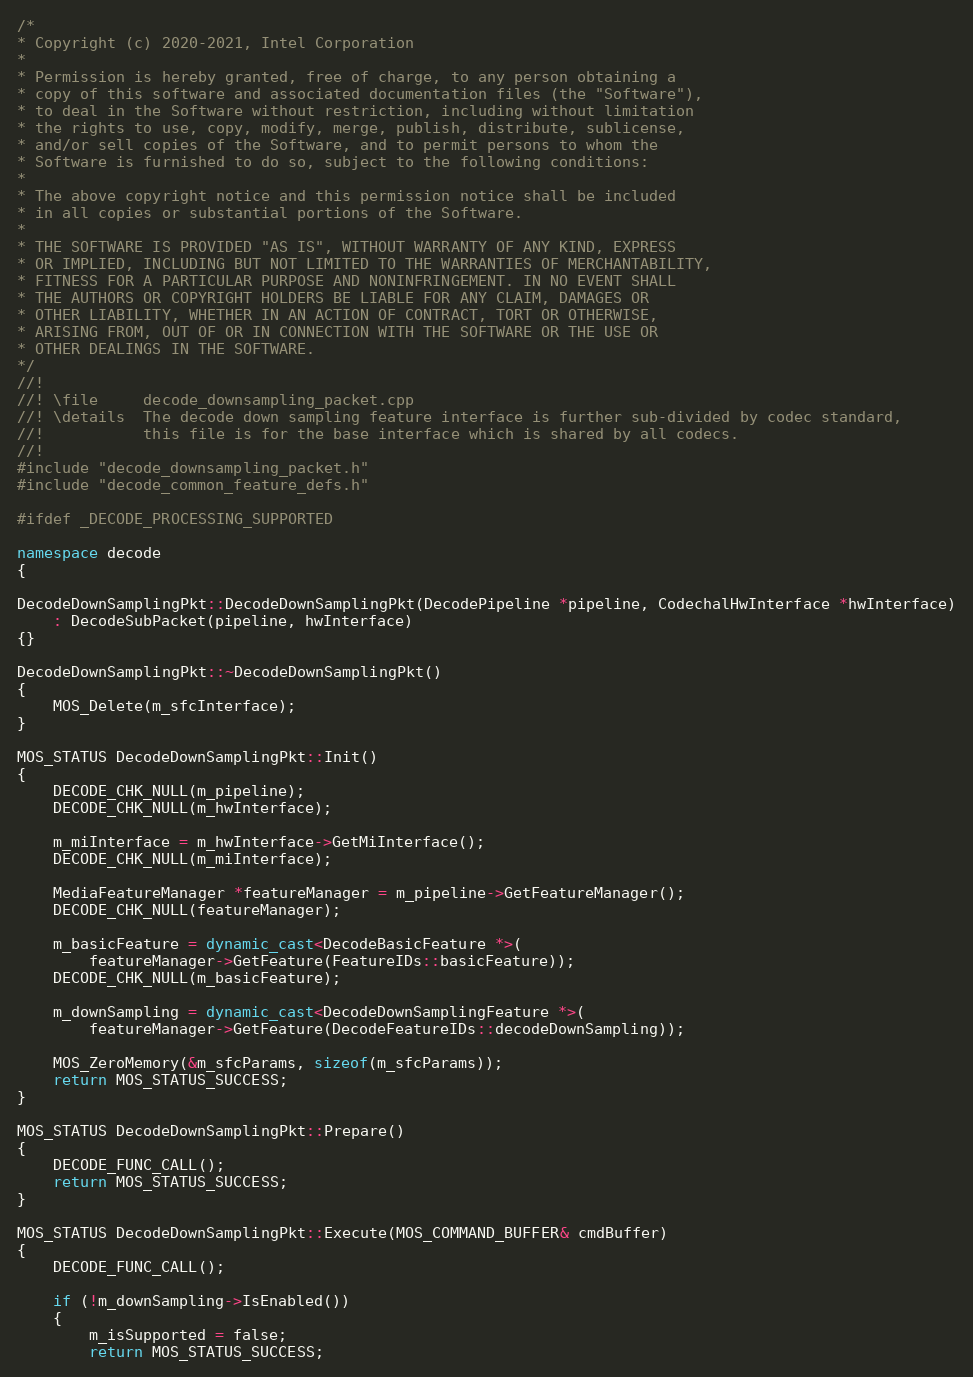<code> <loc_0><loc_0><loc_500><loc_500><_C++_>/*
* Copyright (c) 2020-2021, Intel Corporation
*
* Permission is hereby granted, free of charge, to any person obtaining a
* copy of this software and associated documentation files (the "Software"),
* to deal in the Software without restriction, including without limitation
* the rights to use, copy, modify, merge, publish, distribute, sublicense,
* and/or sell copies of the Software, and to permit persons to whom the
* Software is furnished to do so, subject to the following conditions:
*
* The above copyright notice and this permission notice shall be included
* in all copies or substantial portions of the Software.
*
* THE SOFTWARE IS PROVIDED "AS IS", WITHOUT WARRANTY OF ANY KIND, EXPRESS
* OR IMPLIED, INCLUDING BUT NOT LIMITED TO THE WARRANTIES OF MERCHANTABILITY,
* FITNESS FOR A PARTICULAR PURPOSE AND NONINFRINGEMENT. IN NO EVENT SHALL
* THE AUTHORS OR COPYRIGHT HOLDERS BE LIABLE FOR ANY CLAIM, DAMAGES OR
* OTHER LIABILITY, WHETHER IN AN ACTION OF CONTRACT, TORT OR OTHERWISE,
* ARISING FROM, OUT OF OR IN CONNECTION WITH THE SOFTWARE OR THE USE OR
* OTHER DEALINGS IN THE SOFTWARE.
*/
//!
//! \file     decode_downsampling_packet.cpp
//! \details  The decode down sampling feature interface is further sub-divided by codec standard,
//!           this file is for the base interface which is shared by all codecs.
//!
#include "decode_downsampling_packet.h"
#include "decode_common_feature_defs.h"

#ifdef _DECODE_PROCESSING_SUPPORTED

namespace decode
{

DecodeDownSamplingPkt::DecodeDownSamplingPkt(DecodePipeline *pipeline, CodechalHwInterface *hwInterface)
    : DecodeSubPacket(pipeline, hwInterface)
{}

DecodeDownSamplingPkt::~DecodeDownSamplingPkt()
{
    MOS_Delete(m_sfcInterface);
}

MOS_STATUS DecodeDownSamplingPkt::Init()
{
    DECODE_CHK_NULL(m_pipeline);
    DECODE_CHK_NULL(m_hwInterface);

    m_miInterface = m_hwInterface->GetMiInterface();
    DECODE_CHK_NULL(m_miInterface);

    MediaFeatureManager *featureManager = m_pipeline->GetFeatureManager();
    DECODE_CHK_NULL(featureManager);

    m_basicFeature = dynamic_cast<DecodeBasicFeature *>(
        featureManager->GetFeature(FeatureIDs::basicFeature));
    DECODE_CHK_NULL(m_basicFeature);

    m_downSampling = dynamic_cast<DecodeDownSamplingFeature *>(
        featureManager->GetFeature(DecodeFeatureIDs::decodeDownSampling));

    MOS_ZeroMemory(&m_sfcParams, sizeof(m_sfcParams));
    return MOS_STATUS_SUCCESS;
}

MOS_STATUS DecodeDownSamplingPkt::Prepare()
{
    DECODE_FUNC_CALL();
    return MOS_STATUS_SUCCESS;
}

MOS_STATUS DecodeDownSamplingPkt::Execute(MOS_COMMAND_BUFFER& cmdBuffer)
{
    DECODE_FUNC_CALL();

    if (!m_downSampling->IsEnabled())
    {
        m_isSupported = false;
        return MOS_STATUS_SUCCESS;</code> 